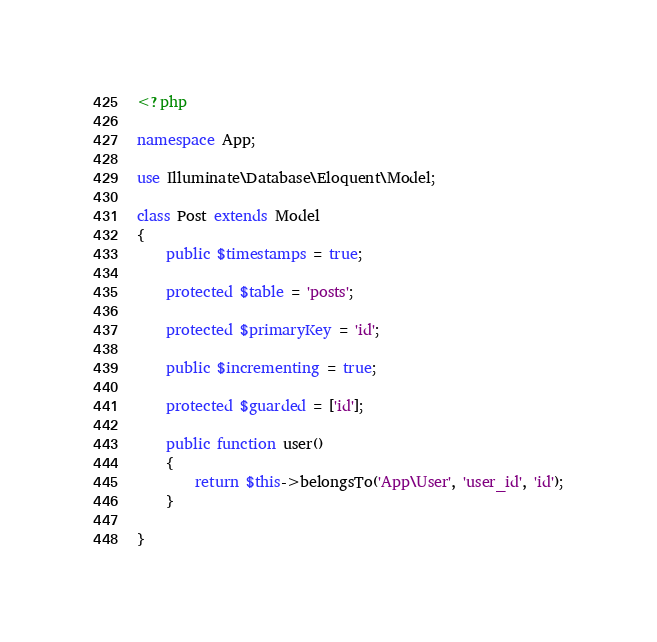Convert code to text. <code><loc_0><loc_0><loc_500><loc_500><_PHP_><?php

namespace App;

use Illuminate\Database\Eloquent\Model;

class Post extends Model
{
    public $timestamps = true;

    protected $table = 'posts';

    protected $primaryKey = 'id';

    public $incrementing = true;

    protected $guarded = ['id'];

    public function user()
    {
        return $this->belongsTo('App\User', 'user_id', 'id');
    }

}
</code> 